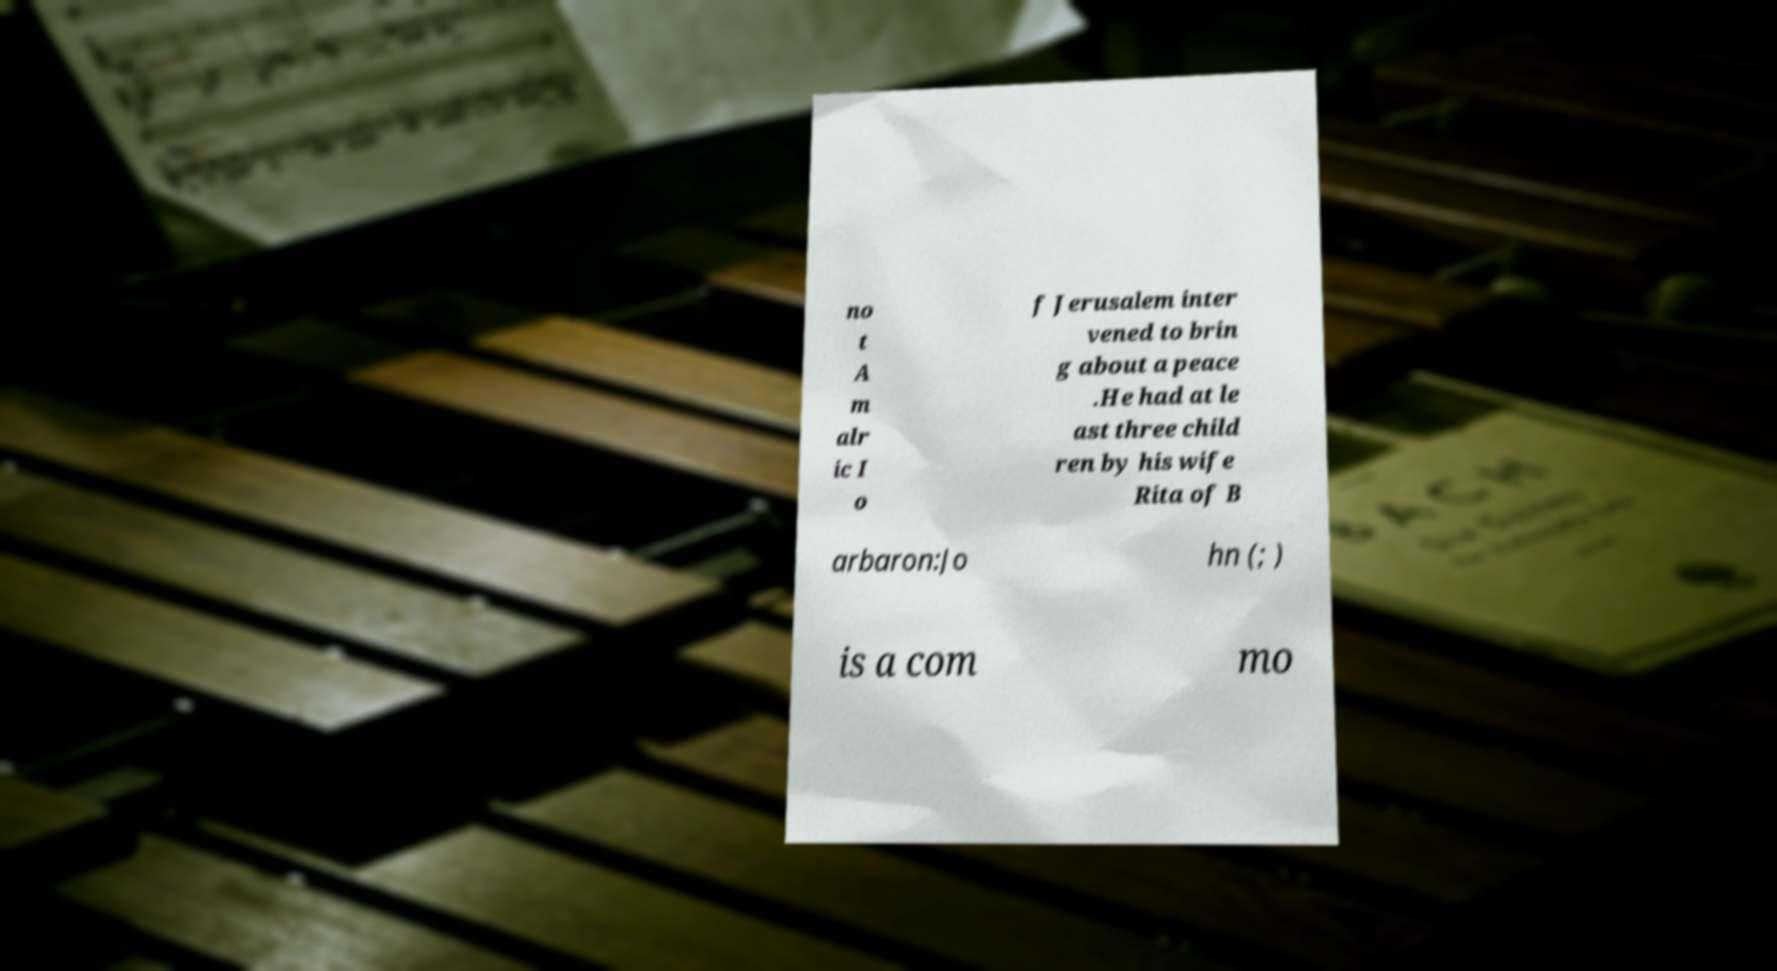Can you accurately transcribe the text from the provided image for me? no t A m alr ic I o f Jerusalem inter vened to brin g about a peace .He had at le ast three child ren by his wife Rita of B arbaron:Jo hn (; ) is a com mo 